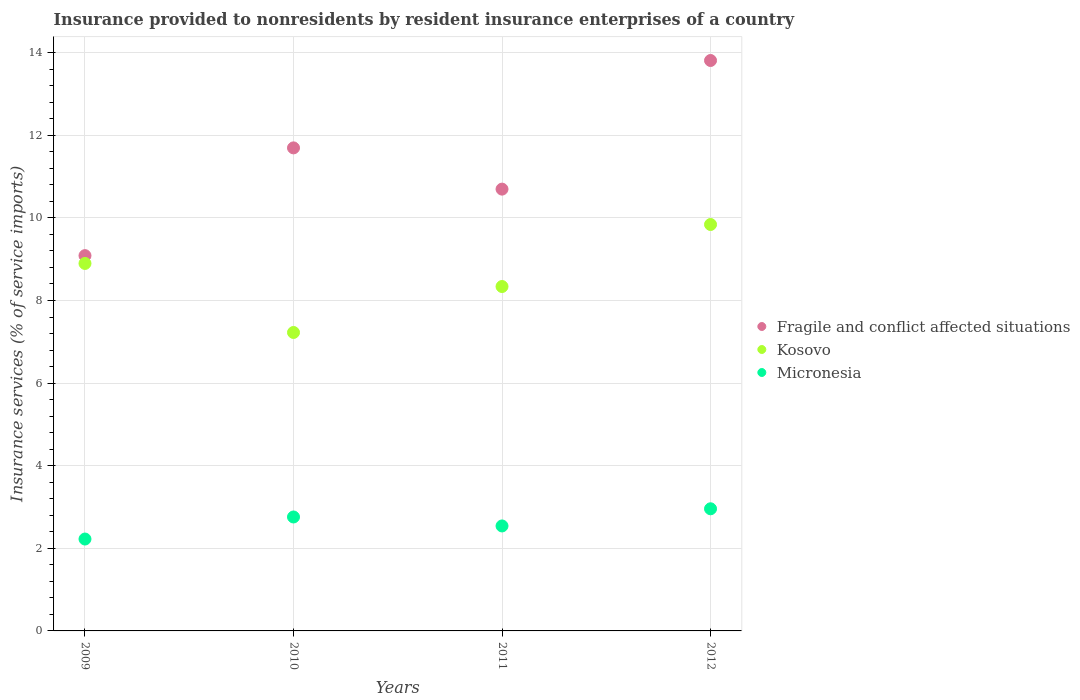Is the number of dotlines equal to the number of legend labels?
Ensure brevity in your answer.  Yes. What is the insurance provided to nonresidents in Fragile and conflict affected situations in 2011?
Make the answer very short. 10.7. Across all years, what is the maximum insurance provided to nonresidents in Kosovo?
Ensure brevity in your answer.  9.84. Across all years, what is the minimum insurance provided to nonresidents in Micronesia?
Offer a terse response. 2.22. In which year was the insurance provided to nonresidents in Micronesia maximum?
Your answer should be compact. 2012. In which year was the insurance provided to nonresidents in Fragile and conflict affected situations minimum?
Provide a short and direct response. 2009. What is the total insurance provided to nonresidents in Fragile and conflict affected situations in the graph?
Provide a short and direct response. 45.29. What is the difference between the insurance provided to nonresidents in Kosovo in 2010 and that in 2012?
Make the answer very short. -2.61. What is the difference between the insurance provided to nonresidents in Micronesia in 2009 and the insurance provided to nonresidents in Kosovo in 2012?
Provide a succinct answer. -7.62. What is the average insurance provided to nonresidents in Micronesia per year?
Your answer should be compact. 2.62. In the year 2011, what is the difference between the insurance provided to nonresidents in Fragile and conflict affected situations and insurance provided to nonresidents in Micronesia?
Give a very brief answer. 8.15. In how many years, is the insurance provided to nonresidents in Micronesia greater than 7.2 %?
Keep it short and to the point. 0. What is the ratio of the insurance provided to nonresidents in Kosovo in 2009 to that in 2010?
Ensure brevity in your answer.  1.23. Is the insurance provided to nonresidents in Kosovo in 2009 less than that in 2012?
Provide a short and direct response. Yes. Is the difference between the insurance provided to nonresidents in Fragile and conflict affected situations in 2011 and 2012 greater than the difference between the insurance provided to nonresidents in Micronesia in 2011 and 2012?
Your answer should be very brief. No. What is the difference between the highest and the second highest insurance provided to nonresidents in Kosovo?
Make the answer very short. 0.94. What is the difference between the highest and the lowest insurance provided to nonresidents in Fragile and conflict affected situations?
Your answer should be compact. 4.72. In how many years, is the insurance provided to nonresidents in Micronesia greater than the average insurance provided to nonresidents in Micronesia taken over all years?
Keep it short and to the point. 2. Is the insurance provided to nonresidents in Kosovo strictly less than the insurance provided to nonresidents in Fragile and conflict affected situations over the years?
Give a very brief answer. Yes. Does the graph contain any zero values?
Make the answer very short. No. What is the title of the graph?
Provide a short and direct response. Insurance provided to nonresidents by resident insurance enterprises of a country. What is the label or title of the Y-axis?
Provide a short and direct response. Insurance services (% of service imports). What is the Insurance services (% of service imports) in Fragile and conflict affected situations in 2009?
Your answer should be compact. 9.09. What is the Insurance services (% of service imports) of Kosovo in 2009?
Ensure brevity in your answer.  8.9. What is the Insurance services (% of service imports) of Micronesia in 2009?
Keep it short and to the point. 2.22. What is the Insurance services (% of service imports) in Fragile and conflict affected situations in 2010?
Provide a succinct answer. 11.69. What is the Insurance services (% of service imports) of Kosovo in 2010?
Provide a succinct answer. 7.23. What is the Insurance services (% of service imports) in Micronesia in 2010?
Ensure brevity in your answer.  2.76. What is the Insurance services (% of service imports) of Fragile and conflict affected situations in 2011?
Make the answer very short. 10.7. What is the Insurance services (% of service imports) in Kosovo in 2011?
Offer a very short reply. 8.34. What is the Insurance services (% of service imports) in Micronesia in 2011?
Provide a succinct answer. 2.54. What is the Insurance services (% of service imports) of Fragile and conflict affected situations in 2012?
Offer a very short reply. 13.81. What is the Insurance services (% of service imports) of Kosovo in 2012?
Offer a terse response. 9.84. What is the Insurance services (% of service imports) of Micronesia in 2012?
Offer a very short reply. 2.96. Across all years, what is the maximum Insurance services (% of service imports) of Fragile and conflict affected situations?
Your answer should be very brief. 13.81. Across all years, what is the maximum Insurance services (% of service imports) of Kosovo?
Give a very brief answer. 9.84. Across all years, what is the maximum Insurance services (% of service imports) of Micronesia?
Provide a short and direct response. 2.96. Across all years, what is the minimum Insurance services (% of service imports) of Fragile and conflict affected situations?
Your answer should be very brief. 9.09. Across all years, what is the minimum Insurance services (% of service imports) of Kosovo?
Keep it short and to the point. 7.23. Across all years, what is the minimum Insurance services (% of service imports) of Micronesia?
Ensure brevity in your answer.  2.22. What is the total Insurance services (% of service imports) of Fragile and conflict affected situations in the graph?
Ensure brevity in your answer.  45.29. What is the total Insurance services (% of service imports) of Kosovo in the graph?
Ensure brevity in your answer.  34.3. What is the total Insurance services (% of service imports) of Micronesia in the graph?
Offer a very short reply. 10.48. What is the difference between the Insurance services (% of service imports) in Fragile and conflict affected situations in 2009 and that in 2010?
Make the answer very short. -2.61. What is the difference between the Insurance services (% of service imports) in Kosovo in 2009 and that in 2010?
Your response must be concise. 1.67. What is the difference between the Insurance services (% of service imports) of Micronesia in 2009 and that in 2010?
Offer a very short reply. -0.53. What is the difference between the Insurance services (% of service imports) in Fragile and conflict affected situations in 2009 and that in 2011?
Your answer should be compact. -1.61. What is the difference between the Insurance services (% of service imports) of Kosovo in 2009 and that in 2011?
Make the answer very short. 0.56. What is the difference between the Insurance services (% of service imports) in Micronesia in 2009 and that in 2011?
Offer a very short reply. -0.32. What is the difference between the Insurance services (% of service imports) in Fragile and conflict affected situations in 2009 and that in 2012?
Offer a terse response. -4.72. What is the difference between the Insurance services (% of service imports) in Kosovo in 2009 and that in 2012?
Provide a short and direct response. -0.94. What is the difference between the Insurance services (% of service imports) in Micronesia in 2009 and that in 2012?
Offer a very short reply. -0.73. What is the difference between the Insurance services (% of service imports) of Fragile and conflict affected situations in 2010 and that in 2011?
Keep it short and to the point. 1. What is the difference between the Insurance services (% of service imports) of Kosovo in 2010 and that in 2011?
Your answer should be very brief. -1.11. What is the difference between the Insurance services (% of service imports) of Micronesia in 2010 and that in 2011?
Your response must be concise. 0.22. What is the difference between the Insurance services (% of service imports) of Fragile and conflict affected situations in 2010 and that in 2012?
Your answer should be very brief. -2.12. What is the difference between the Insurance services (% of service imports) of Kosovo in 2010 and that in 2012?
Provide a short and direct response. -2.61. What is the difference between the Insurance services (% of service imports) of Micronesia in 2010 and that in 2012?
Give a very brief answer. -0.2. What is the difference between the Insurance services (% of service imports) of Fragile and conflict affected situations in 2011 and that in 2012?
Your answer should be very brief. -3.11. What is the difference between the Insurance services (% of service imports) of Kosovo in 2011 and that in 2012?
Offer a very short reply. -1.5. What is the difference between the Insurance services (% of service imports) in Micronesia in 2011 and that in 2012?
Offer a very short reply. -0.42. What is the difference between the Insurance services (% of service imports) in Fragile and conflict affected situations in 2009 and the Insurance services (% of service imports) in Kosovo in 2010?
Make the answer very short. 1.86. What is the difference between the Insurance services (% of service imports) in Fragile and conflict affected situations in 2009 and the Insurance services (% of service imports) in Micronesia in 2010?
Your answer should be compact. 6.33. What is the difference between the Insurance services (% of service imports) of Kosovo in 2009 and the Insurance services (% of service imports) of Micronesia in 2010?
Offer a very short reply. 6.14. What is the difference between the Insurance services (% of service imports) of Fragile and conflict affected situations in 2009 and the Insurance services (% of service imports) of Kosovo in 2011?
Make the answer very short. 0.75. What is the difference between the Insurance services (% of service imports) of Fragile and conflict affected situations in 2009 and the Insurance services (% of service imports) of Micronesia in 2011?
Your answer should be compact. 6.54. What is the difference between the Insurance services (% of service imports) of Kosovo in 2009 and the Insurance services (% of service imports) of Micronesia in 2011?
Your answer should be compact. 6.36. What is the difference between the Insurance services (% of service imports) in Fragile and conflict affected situations in 2009 and the Insurance services (% of service imports) in Kosovo in 2012?
Make the answer very short. -0.75. What is the difference between the Insurance services (% of service imports) in Fragile and conflict affected situations in 2009 and the Insurance services (% of service imports) in Micronesia in 2012?
Your answer should be very brief. 6.13. What is the difference between the Insurance services (% of service imports) in Kosovo in 2009 and the Insurance services (% of service imports) in Micronesia in 2012?
Give a very brief answer. 5.94. What is the difference between the Insurance services (% of service imports) in Fragile and conflict affected situations in 2010 and the Insurance services (% of service imports) in Kosovo in 2011?
Keep it short and to the point. 3.36. What is the difference between the Insurance services (% of service imports) of Fragile and conflict affected situations in 2010 and the Insurance services (% of service imports) of Micronesia in 2011?
Keep it short and to the point. 9.15. What is the difference between the Insurance services (% of service imports) in Kosovo in 2010 and the Insurance services (% of service imports) in Micronesia in 2011?
Keep it short and to the point. 4.68. What is the difference between the Insurance services (% of service imports) in Fragile and conflict affected situations in 2010 and the Insurance services (% of service imports) in Kosovo in 2012?
Provide a short and direct response. 1.85. What is the difference between the Insurance services (% of service imports) of Fragile and conflict affected situations in 2010 and the Insurance services (% of service imports) of Micronesia in 2012?
Your answer should be very brief. 8.74. What is the difference between the Insurance services (% of service imports) in Kosovo in 2010 and the Insurance services (% of service imports) in Micronesia in 2012?
Offer a terse response. 4.27. What is the difference between the Insurance services (% of service imports) in Fragile and conflict affected situations in 2011 and the Insurance services (% of service imports) in Kosovo in 2012?
Offer a terse response. 0.86. What is the difference between the Insurance services (% of service imports) of Fragile and conflict affected situations in 2011 and the Insurance services (% of service imports) of Micronesia in 2012?
Give a very brief answer. 7.74. What is the difference between the Insurance services (% of service imports) of Kosovo in 2011 and the Insurance services (% of service imports) of Micronesia in 2012?
Your response must be concise. 5.38. What is the average Insurance services (% of service imports) in Fragile and conflict affected situations per year?
Make the answer very short. 11.32. What is the average Insurance services (% of service imports) of Kosovo per year?
Give a very brief answer. 8.58. What is the average Insurance services (% of service imports) in Micronesia per year?
Give a very brief answer. 2.62. In the year 2009, what is the difference between the Insurance services (% of service imports) in Fragile and conflict affected situations and Insurance services (% of service imports) in Kosovo?
Your response must be concise. 0.19. In the year 2009, what is the difference between the Insurance services (% of service imports) of Fragile and conflict affected situations and Insurance services (% of service imports) of Micronesia?
Your response must be concise. 6.86. In the year 2009, what is the difference between the Insurance services (% of service imports) of Kosovo and Insurance services (% of service imports) of Micronesia?
Your answer should be very brief. 6.67. In the year 2010, what is the difference between the Insurance services (% of service imports) of Fragile and conflict affected situations and Insurance services (% of service imports) of Kosovo?
Provide a succinct answer. 4.47. In the year 2010, what is the difference between the Insurance services (% of service imports) of Fragile and conflict affected situations and Insurance services (% of service imports) of Micronesia?
Your response must be concise. 8.94. In the year 2010, what is the difference between the Insurance services (% of service imports) in Kosovo and Insurance services (% of service imports) in Micronesia?
Provide a succinct answer. 4.47. In the year 2011, what is the difference between the Insurance services (% of service imports) of Fragile and conflict affected situations and Insurance services (% of service imports) of Kosovo?
Make the answer very short. 2.36. In the year 2011, what is the difference between the Insurance services (% of service imports) of Fragile and conflict affected situations and Insurance services (% of service imports) of Micronesia?
Make the answer very short. 8.15. In the year 2011, what is the difference between the Insurance services (% of service imports) of Kosovo and Insurance services (% of service imports) of Micronesia?
Your answer should be compact. 5.8. In the year 2012, what is the difference between the Insurance services (% of service imports) of Fragile and conflict affected situations and Insurance services (% of service imports) of Kosovo?
Give a very brief answer. 3.97. In the year 2012, what is the difference between the Insurance services (% of service imports) of Fragile and conflict affected situations and Insurance services (% of service imports) of Micronesia?
Give a very brief answer. 10.85. In the year 2012, what is the difference between the Insurance services (% of service imports) of Kosovo and Insurance services (% of service imports) of Micronesia?
Provide a short and direct response. 6.88. What is the ratio of the Insurance services (% of service imports) of Fragile and conflict affected situations in 2009 to that in 2010?
Your response must be concise. 0.78. What is the ratio of the Insurance services (% of service imports) in Kosovo in 2009 to that in 2010?
Provide a succinct answer. 1.23. What is the ratio of the Insurance services (% of service imports) of Micronesia in 2009 to that in 2010?
Provide a succinct answer. 0.81. What is the ratio of the Insurance services (% of service imports) in Fragile and conflict affected situations in 2009 to that in 2011?
Offer a terse response. 0.85. What is the ratio of the Insurance services (% of service imports) of Kosovo in 2009 to that in 2011?
Make the answer very short. 1.07. What is the ratio of the Insurance services (% of service imports) in Micronesia in 2009 to that in 2011?
Offer a terse response. 0.88. What is the ratio of the Insurance services (% of service imports) in Fragile and conflict affected situations in 2009 to that in 2012?
Ensure brevity in your answer.  0.66. What is the ratio of the Insurance services (% of service imports) in Kosovo in 2009 to that in 2012?
Provide a succinct answer. 0.9. What is the ratio of the Insurance services (% of service imports) in Micronesia in 2009 to that in 2012?
Give a very brief answer. 0.75. What is the ratio of the Insurance services (% of service imports) of Fragile and conflict affected situations in 2010 to that in 2011?
Make the answer very short. 1.09. What is the ratio of the Insurance services (% of service imports) of Kosovo in 2010 to that in 2011?
Keep it short and to the point. 0.87. What is the ratio of the Insurance services (% of service imports) in Micronesia in 2010 to that in 2011?
Provide a succinct answer. 1.09. What is the ratio of the Insurance services (% of service imports) in Fragile and conflict affected situations in 2010 to that in 2012?
Make the answer very short. 0.85. What is the ratio of the Insurance services (% of service imports) in Kosovo in 2010 to that in 2012?
Your response must be concise. 0.73. What is the ratio of the Insurance services (% of service imports) in Micronesia in 2010 to that in 2012?
Your answer should be very brief. 0.93. What is the ratio of the Insurance services (% of service imports) of Fragile and conflict affected situations in 2011 to that in 2012?
Provide a succinct answer. 0.77. What is the ratio of the Insurance services (% of service imports) of Kosovo in 2011 to that in 2012?
Make the answer very short. 0.85. What is the ratio of the Insurance services (% of service imports) of Micronesia in 2011 to that in 2012?
Provide a succinct answer. 0.86. What is the difference between the highest and the second highest Insurance services (% of service imports) of Fragile and conflict affected situations?
Ensure brevity in your answer.  2.12. What is the difference between the highest and the second highest Insurance services (% of service imports) of Kosovo?
Your answer should be very brief. 0.94. What is the difference between the highest and the second highest Insurance services (% of service imports) in Micronesia?
Your answer should be compact. 0.2. What is the difference between the highest and the lowest Insurance services (% of service imports) of Fragile and conflict affected situations?
Make the answer very short. 4.72. What is the difference between the highest and the lowest Insurance services (% of service imports) in Kosovo?
Your answer should be very brief. 2.61. What is the difference between the highest and the lowest Insurance services (% of service imports) of Micronesia?
Make the answer very short. 0.73. 